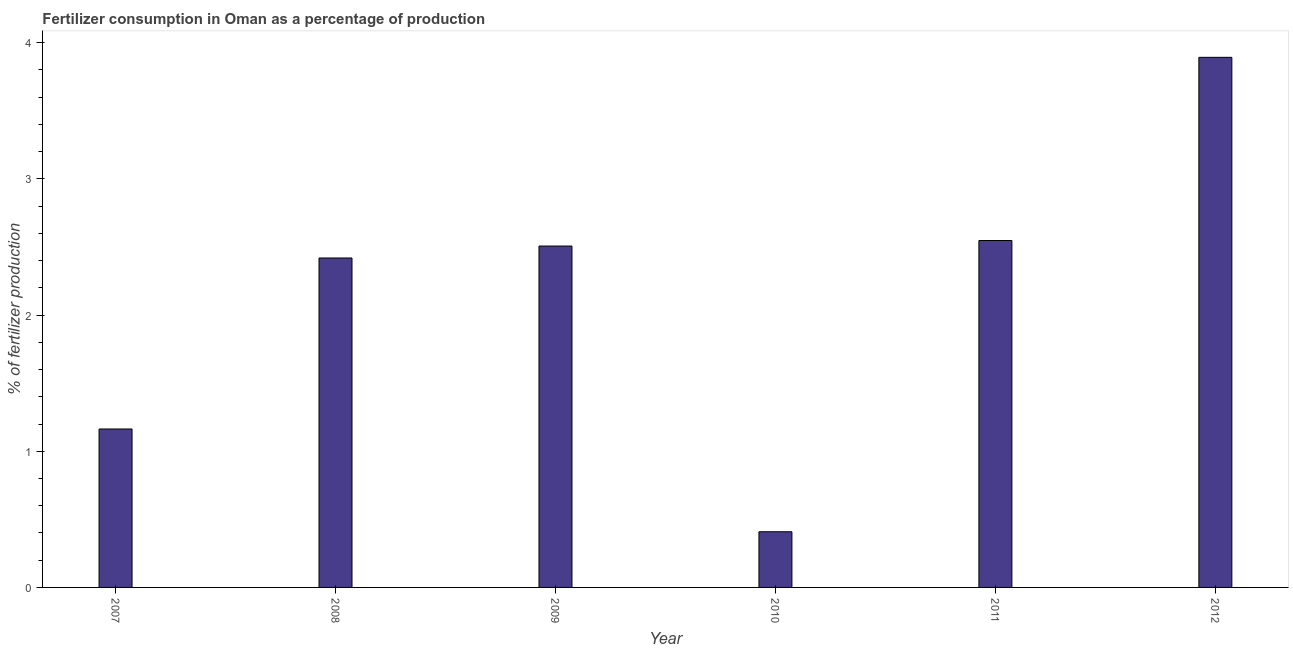What is the title of the graph?
Offer a very short reply. Fertilizer consumption in Oman as a percentage of production. What is the label or title of the Y-axis?
Make the answer very short. % of fertilizer production. What is the amount of fertilizer consumption in 2009?
Your answer should be compact. 2.51. Across all years, what is the maximum amount of fertilizer consumption?
Make the answer very short. 3.89. Across all years, what is the minimum amount of fertilizer consumption?
Give a very brief answer. 0.41. What is the sum of the amount of fertilizer consumption?
Ensure brevity in your answer.  12.94. What is the difference between the amount of fertilizer consumption in 2007 and 2009?
Your answer should be very brief. -1.34. What is the average amount of fertilizer consumption per year?
Make the answer very short. 2.16. What is the median amount of fertilizer consumption?
Your answer should be compact. 2.46. Do a majority of the years between 2010 and 2007 (inclusive) have amount of fertilizer consumption greater than 1.8 %?
Ensure brevity in your answer.  Yes. What is the ratio of the amount of fertilizer consumption in 2007 to that in 2008?
Provide a short and direct response. 0.48. Is the amount of fertilizer consumption in 2007 less than that in 2008?
Offer a terse response. Yes. What is the difference between the highest and the second highest amount of fertilizer consumption?
Keep it short and to the point. 1.34. Is the sum of the amount of fertilizer consumption in 2007 and 2010 greater than the maximum amount of fertilizer consumption across all years?
Provide a succinct answer. No. What is the difference between the highest and the lowest amount of fertilizer consumption?
Ensure brevity in your answer.  3.48. In how many years, is the amount of fertilizer consumption greater than the average amount of fertilizer consumption taken over all years?
Keep it short and to the point. 4. Are all the bars in the graph horizontal?
Keep it short and to the point. No. How many years are there in the graph?
Offer a terse response. 6. Are the values on the major ticks of Y-axis written in scientific E-notation?
Give a very brief answer. No. What is the % of fertilizer production of 2007?
Ensure brevity in your answer.  1.16. What is the % of fertilizer production in 2008?
Keep it short and to the point. 2.42. What is the % of fertilizer production in 2009?
Keep it short and to the point. 2.51. What is the % of fertilizer production of 2010?
Offer a terse response. 0.41. What is the % of fertilizer production of 2011?
Your answer should be compact. 2.55. What is the % of fertilizer production in 2012?
Offer a very short reply. 3.89. What is the difference between the % of fertilizer production in 2007 and 2008?
Ensure brevity in your answer.  -1.26. What is the difference between the % of fertilizer production in 2007 and 2009?
Ensure brevity in your answer.  -1.34. What is the difference between the % of fertilizer production in 2007 and 2010?
Ensure brevity in your answer.  0.75. What is the difference between the % of fertilizer production in 2007 and 2011?
Your answer should be very brief. -1.38. What is the difference between the % of fertilizer production in 2007 and 2012?
Your response must be concise. -2.73. What is the difference between the % of fertilizer production in 2008 and 2009?
Provide a short and direct response. -0.09. What is the difference between the % of fertilizer production in 2008 and 2010?
Offer a terse response. 2.01. What is the difference between the % of fertilizer production in 2008 and 2011?
Provide a short and direct response. -0.13. What is the difference between the % of fertilizer production in 2008 and 2012?
Ensure brevity in your answer.  -1.47. What is the difference between the % of fertilizer production in 2009 and 2010?
Provide a succinct answer. 2.1. What is the difference between the % of fertilizer production in 2009 and 2011?
Your answer should be compact. -0.04. What is the difference between the % of fertilizer production in 2009 and 2012?
Offer a terse response. -1.39. What is the difference between the % of fertilizer production in 2010 and 2011?
Provide a succinct answer. -2.14. What is the difference between the % of fertilizer production in 2010 and 2012?
Give a very brief answer. -3.48. What is the difference between the % of fertilizer production in 2011 and 2012?
Your answer should be compact. -1.35. What is the ratio of the % of fertilizer production in 2007 to that in 2008?
Ensure brevity in your answer.  0.48. What is the ratio of the % of fertilizer production in 2007 to that in 2009?
Provide a short and direct response. 0.46. What is the ratio of the % of fertilizer production in 2007 to that in 2010?
Your answer should be compact. 2.85. What is the ratio of the % of fertilizer production in 2007 to that in 2011?
Your answer should be very brief. 0.46. What is the ratio of the % of fertilizer production in 2007 to that in 2012?
Ensure brevity in your answer.  0.3. What is the ratio of the % of fertilizer production in 2008 to that in 2009?
Your response must be concise. 0.96. What is the ratio of the % of fertilizer production in 2008 to that in 2010?
Your answer should be compact. 5.92. What is the ratio of the % of fertilizer production in 2008 to that in 2011?
Your response must be concise. 0.95. What is the ratio of the % of fertilizer production in 2008 to that in 2012?
Your answer should be compact. 0.62. What is the ratio of the % of fertilizer production in 2009 to that in 2010?
Offer a terse response. 6.13. What is the ratio of the % of fertilizer production in 2009 to that in 2011?
Make the answer very short. 0.98. What is the ratio of the % of fertilizer production in 2009 to that in 2012?
Make the answer very short. 0.64. What is the ratio of the % of fertilizer production in 2010 to that in 2011?
Your response must be concise. 0.16. What is the ratio of the % of fertilizer production in 2010 to that in 2012?
Keep it short and to the point. 0.1. What is the ratio of the % of fertilizer production in 2011 to that in 2012?
Your answer should be compact. 0.65. 